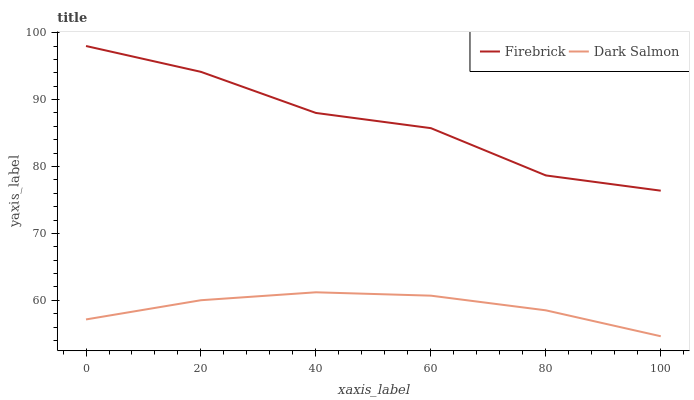Does Dark Salmon have the minimum area under the curve?
Answer yes or no. Yes. Does Firebrick have the maximum area under the curve?
Answer yes or no. Yes. Does Dark Salmon have the maximum area under the curve?
Answer yes or no. No. Is Dark Salmon the smoothest?
Answer yes or no. Yes. Is Firebrick the roughest?
Answer yes or no. Yes. Is Dark Salmon the roughest?
Answer yes or no. No. Does Firebrick have the highest value?
Answer yes or no. Yes. Does Dark Salmon have the highest value?
Answer yes or no. No. Is Dark Salmon less than Firebrick?
Answer yes or no. Yes. Is Firebrick greater than Dark Salmon?
Answer yes or no. Yes. Does Dark Salmon intersect Firebrick?
Answer yes or no. No. 